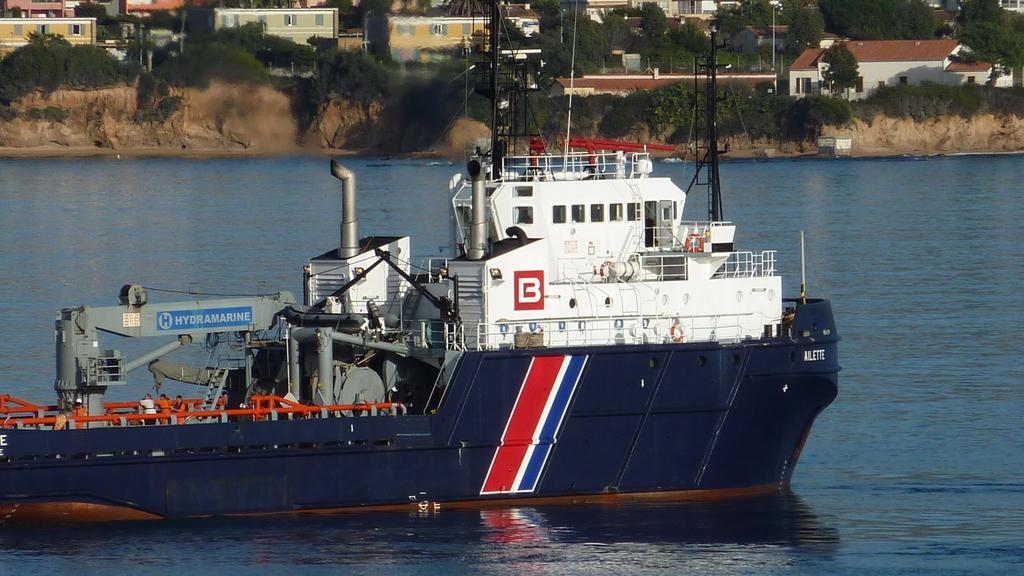What is the main subject in the center of the image? There is a ship in the center of the image. What is located at the bottom of the image? There is water at the bottom of the image. What can be seen in the background of the image? There are houses and trees in the background of the image. How does the wren rest on the ship in the image? There is no wren present in the image, so it cannot rest on the ship. 